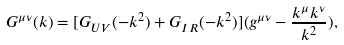Convert formula to latex. <formula><loc_0><loc_0><loc_500><loc_500>G ^ { \mu \nu } ( k ) = [ G _ { U V } ( - k ^ { 2 } ) + G _ { I R } ( - k ^ { 2 } ) ] ( g ^ { \mu \nu } - \frac { k ^ { \mu } k ^ { \nu } } { k ^ { 2 } } ) ,</formula> 